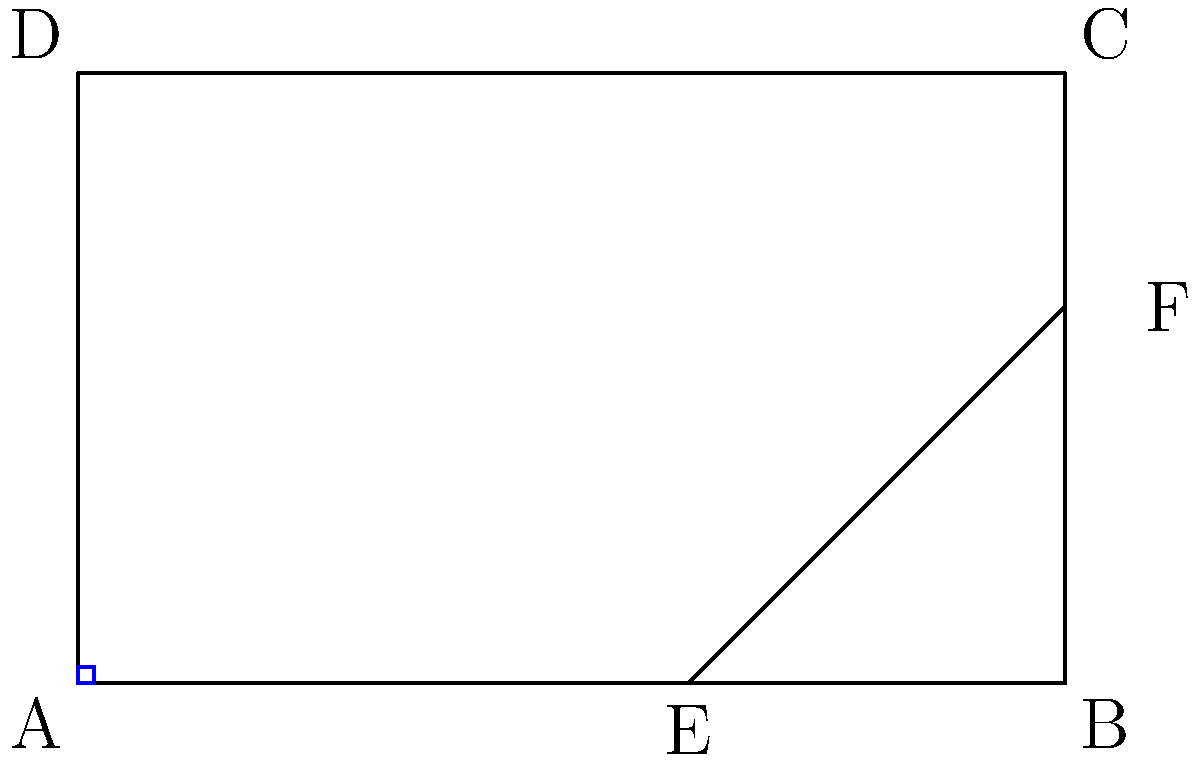In the diagram above, rectangle ABCD represents a book cover layout incorporating the golden ratio. If the width of the cover (AB) is 6 units, and point E divides AB in the golden ratio, what is the length of EF to the nearest hundredth? Let's approach this step-by-step:

1) The golden ratio is approximately 1.618. If AB is divided in the golden ratio at E, then:
   $\frac{AE}{EB} = \frac{AB}{AE} \approx 1.618$

2) Given AB = 6 units, we can find AE:
   $\frac{6}{AE} \approx 1.618$
   $AE \approx \frac{6}{1.618} \approx 3.708$ units

3) Therefore, EB = 6 - 3.708 = 2.292 units

4) In a golden rectangle, the ratio of length to width is also the golden ratio. So:
   $\frac{BC}{AB} \approx 1.618$
   $BC \approx 6 * 1.618 \approx 9.708$ units

5) The height of the rectangle (DC) is:
   $DC = BC - AB = 9.708 - 6 = 3.708$ units

6) Now, we need to find EF. Note that triangles AED and EFB are similar (they share an angle at E, and both have a right angle).

7) The ratio of their sides will be the same as the ratio AE:EB. We can set up the proportion:
   $\frac{EF}{DC} = \frac{EB}{AB}$

8) Substituting the known values:
   $\frac{EF}{3.708} = \frac{2.292}{6}$

9) Cross multiply:
   $6EF = 3.708 * 2.292$

10) Solve for EF:
    $EF = \frac{3.708 * 2.292}{6} \approx 1.42$ units

Therefore, to the nearest hundredth, EF is 1.42 units.
Answer: 1.42 units 